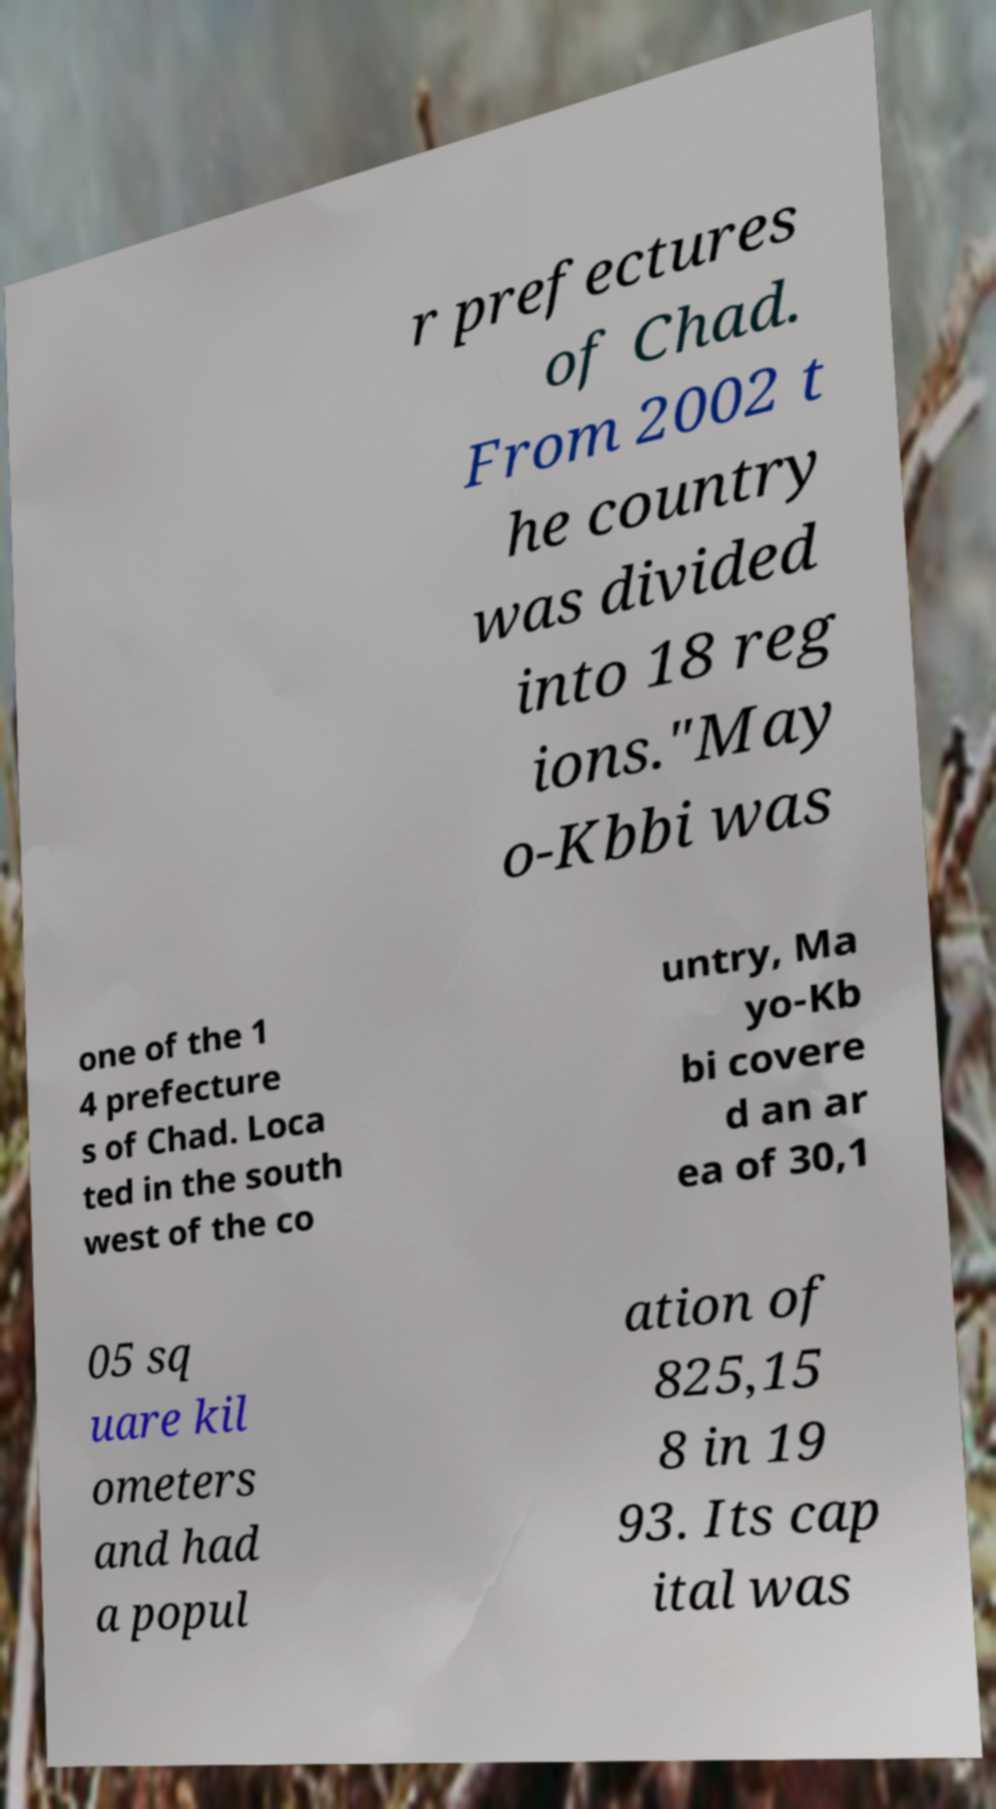Can you read and provide the text displayed in the image?This photo seems to have some interesting text. Can you extract and type it out for me? r prefectures of Chad. From 2002 t he country was divided into 18 reg ions."May o-Kbbi was one of the 1 4 prefecture s of Chad. Loca ted in the south west of the co untry, Ma yo-Kb bi covere d an ar ea of 30,1 05 sq uare kil ometers and had a popul ation of 825,15 8 in 19 93. Its cap ital was 